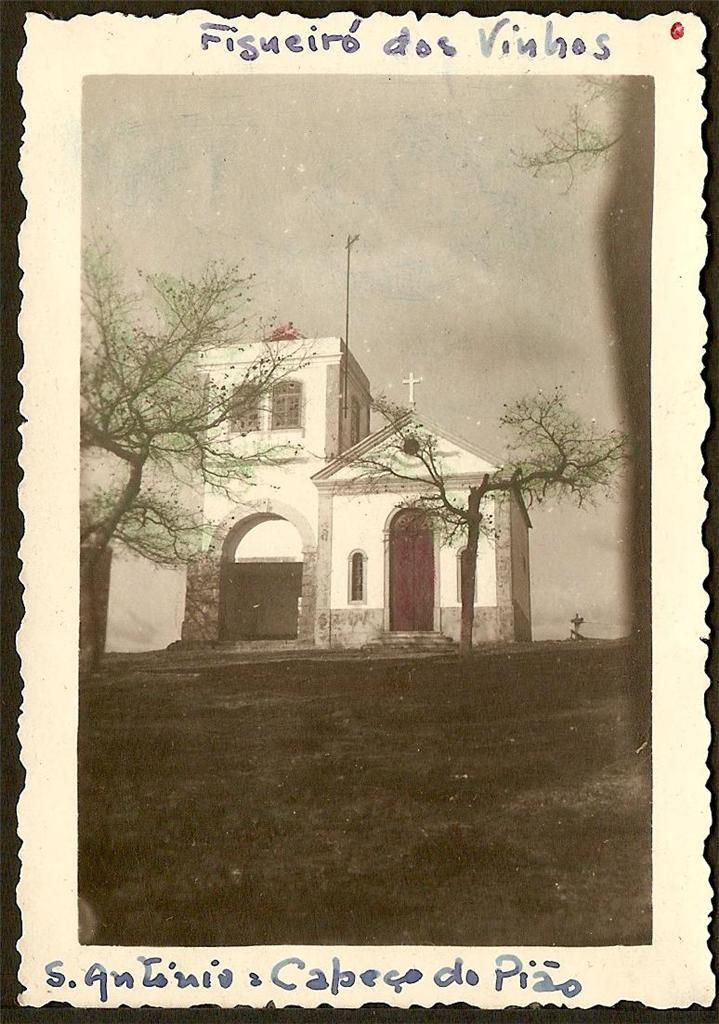<image>
Provide a brief description of the given image. A vintage drawing of a church has writing underneath it that says, "s. Antinia Capecodo do Piao. 